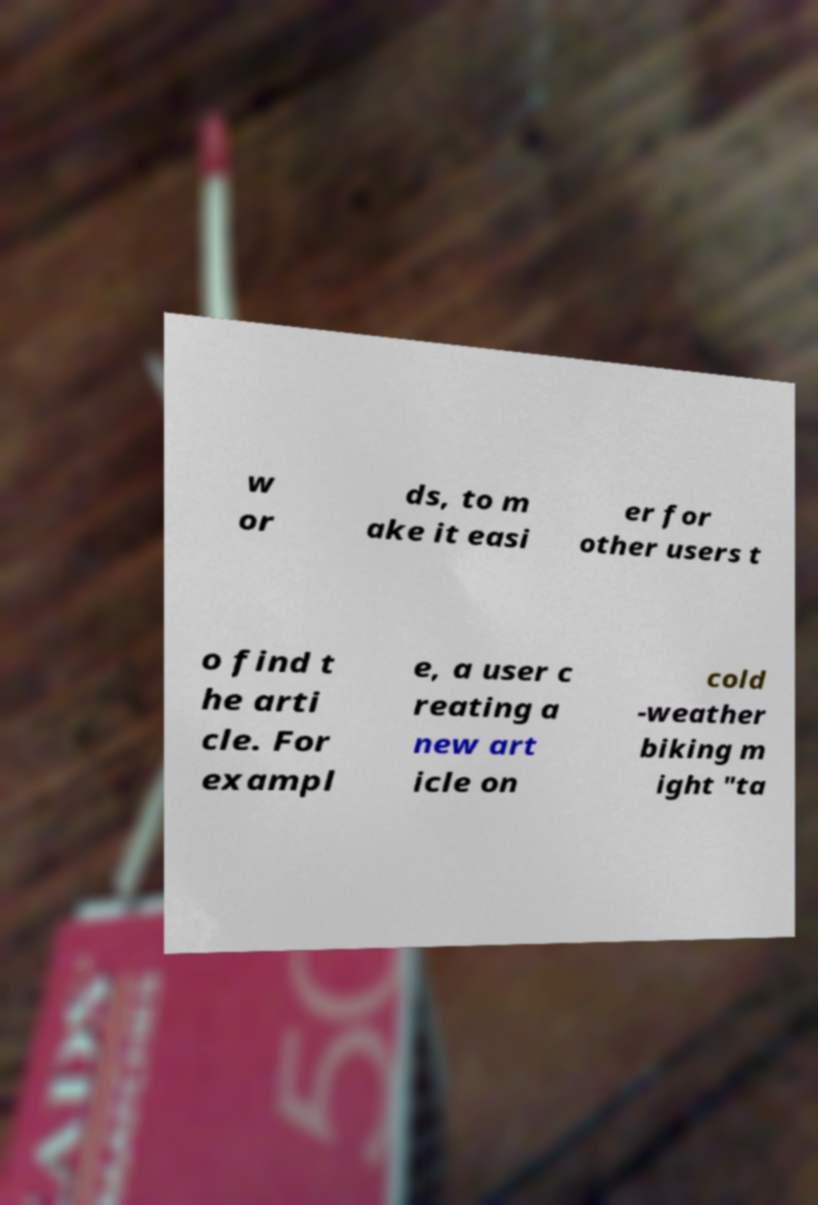Could you extract and type out the text from this image? w or ds, to m ake it easi er for other users t o find t he arti cle. For exampl e, a user c reating a new art icle on cold -weather biking m ight "ta 